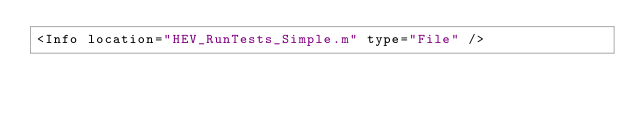Convert code to text. <code><loc_0><loc_0><loc_500><loc_500><_XML_><Info location="HEV_RunTests_Simple.m" type="File" /></code> 